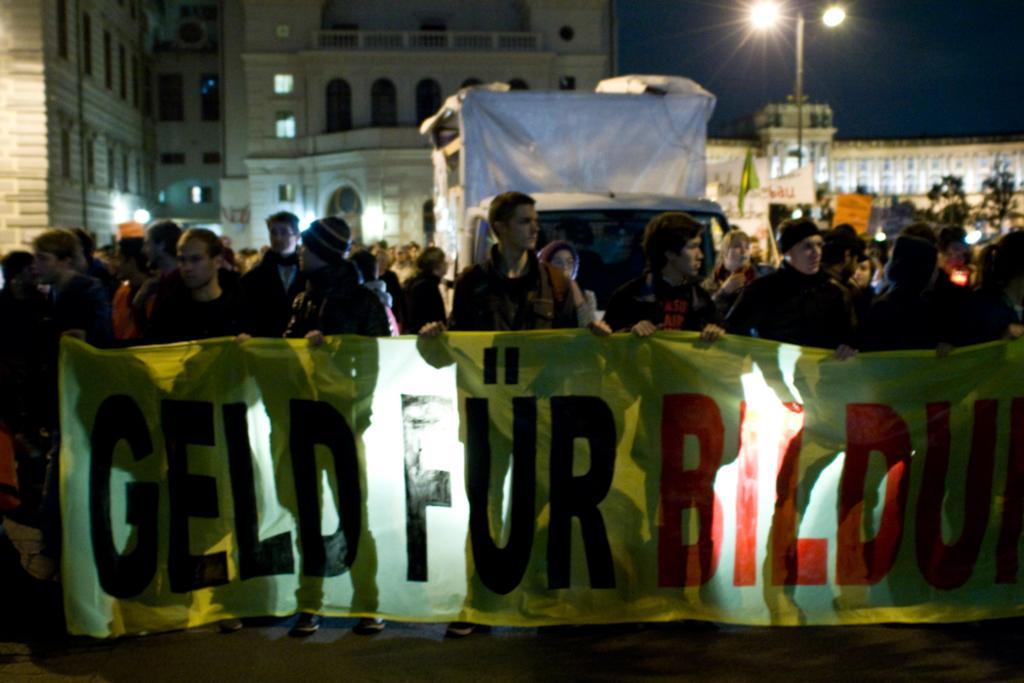Could you give a brief overview of what you see in this image? This picture is clicked outside. In the foreground we can see the group of persons standing and holding a banner on which we can see the text. In the background we can see the sky, lights, flag, vehicle, buildings, windows of the buildings and we can see the group of persons and many other objects. 